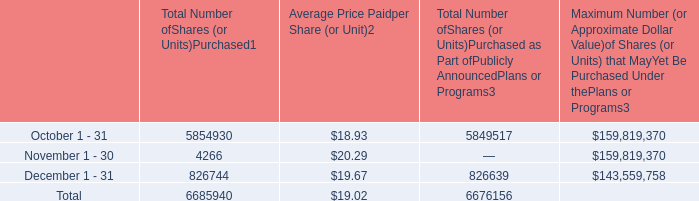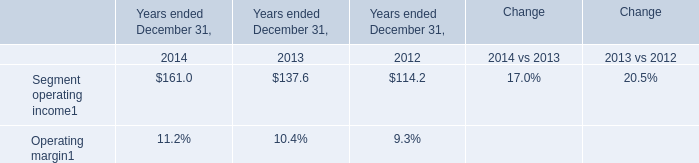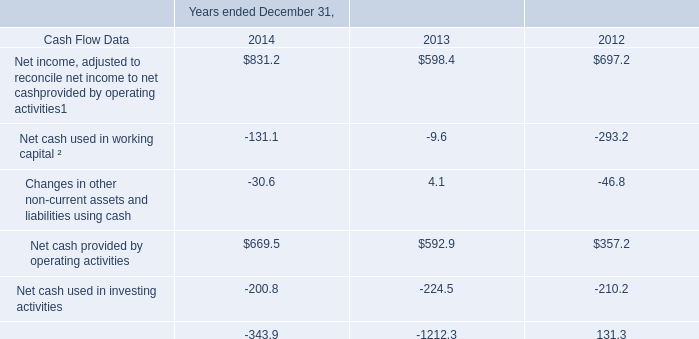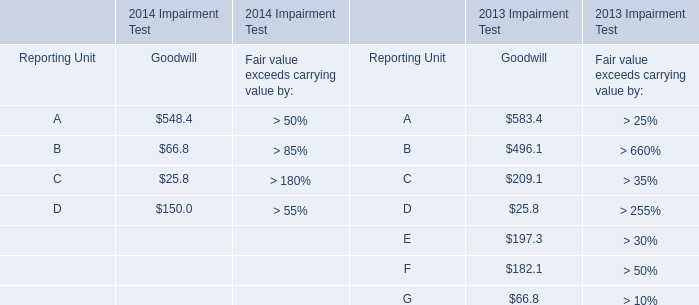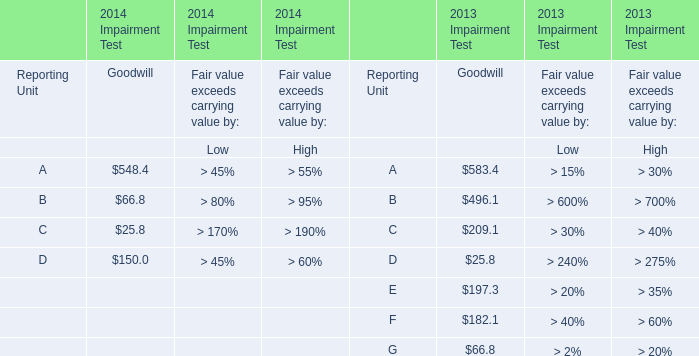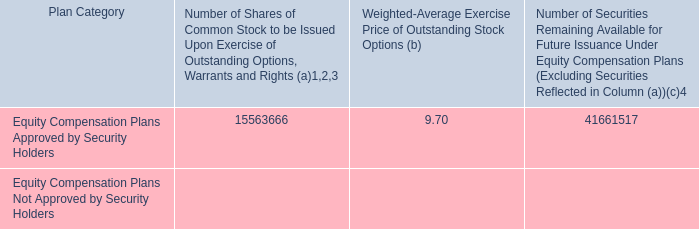For 2013 Impairment Test,how much is the value of the Goodwill of C higher than the value of the Goodwill of E? 
Computations: (209.1 - 197.3)
Answer: 11.8. 